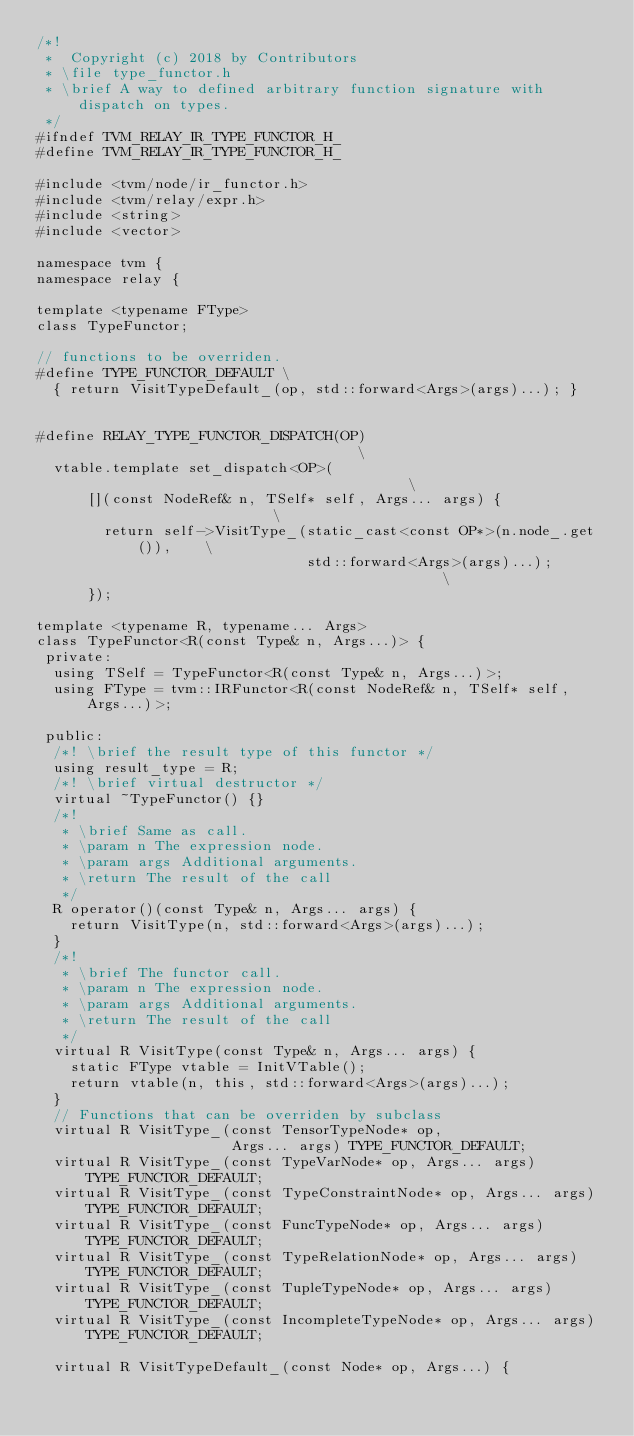<code> <loc_0><loc_0><loc_500><loc_500><_C_>/*!
 *  Copyright (c) 2018 by Contributors
 * \file type_functor.h
 * \brief A way to defined arbitrary function signature with dispatch on types.
 */
#ifndef TVM_RELAY_IR_TYPE_FUNCTOR_H_
#define TVM_RELAY_IR_TYPE_FUNCTOR_H_

#include <tvm/node/ir_functor.h>
#include <tvm/relay/expr.h>
#include <string>
#include <vector>

namespace tvm {
namespace relay {

template <typename FType>
class TypeFunctor;

// functions to be overriden.
#define TYPE_FUNCTOR_DEFAULT \
  { return VisitTypeDefault_(op, std::forward<Args>(args)...); }


#define RELAY_TYPE_FUNCTOR_DISPATCH(OP)                                   \
  vtable.template set_dispatch<OP>(                                       \
      [](const NodeRef& n, TSelf* self, Args... args) {                   \
        return self->VisitType_(static_cast<const OP*>(n.node_.get()),    \
                                std::forward<Args>(args)...);             \
      });

template <typename R, typename... Args>
class TypeFunctor<R(const Type& n, Args...)> {
 private:
  using TSelf = TypeFunctor<R(const Type& n, Args...)>;
  using FType = tvm::IRFunctor<R(const NodeRef& n, TSelf* self, Args...)>;

 public:
  /*! \brief the result type of this functor */
  using result_type = R;
  /*! \brief virtual destructor */
  virtual ~TypeFunctor() {}
  /*!
   * \brief Same as call.
   * \param n The expression node.
   * \param args Additional arguments.
   * \return The result of the call
   */
  R operator()(const Type& n, Args... args) {
    return VisitType(n, std::forward<Args>(args)...);
  }
  /*!
   * \brief The functor call.
   * \param n The expression node.
   * \param args Additional arguments.
   * \return The result of the call
   */
  virtual R VisitType(const Type& n, Args... args) {
    static FType vtable = InitVTable();
    return vtable(n, this, std::forward<Args>(args)...);
  }
  // Functions that can be overriden by subclass
  virtual R VisitType_(const TensorTypeNode* op,
                       Args... args) TYPE_FUNCTOR_DEFAULT;
  virtual R VisitType_(const TypeVarNode* op, Args... args) TYPE_FUNCTOR_DEFAULT;
  virtual R VisitType_(const TypeConstraintNode* op, Args... args) TYPE_FUNCTOR_DEFAULT;
  virtual R VisitType_(const FuncTypeNode* op, Args... args) TYPE_FUNCTOR_DEFAULT;
  virtual R VisitType_(const TypeRelationNode* op, Args... args) TYPE_FUNCTOR_DEFAULT;
  virtual R VisitType_(const TupleTypeNode* op, Args... args) TYPE_FUNCTOR_DEFAULT;
  virtual R VisitType_(const IncompleteTypeNode* op, Args... args) TYPE_FUNCTOR_DEFAULT;

  virtual R VisitTypeDefault_(const Node* op, Args...) {</code> 